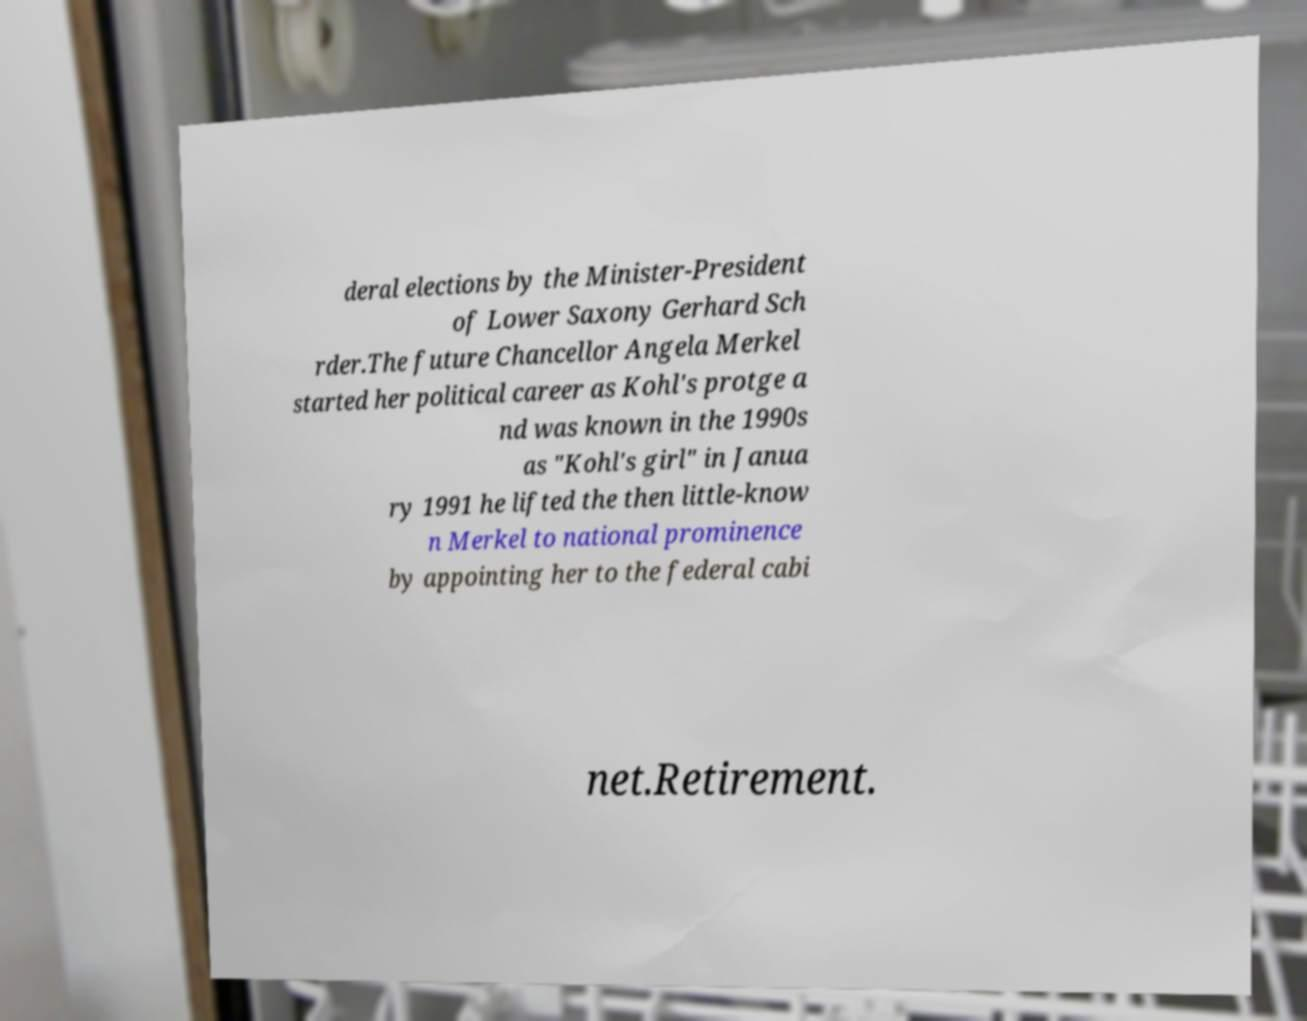Please read and relay the text visible in this image. What does it say? deral elections by the Minister-President of Lower Saxony Gerhard Sch rder.The future Chancellor Angela Merkel started her political career as Kohl's protge a nd was known in the 1990s as "Kohl's girl" in Janua ry 1991 he lifted the then little-know n Merkel to national prominence by appointing her to the federal cabi net.Retirement. 